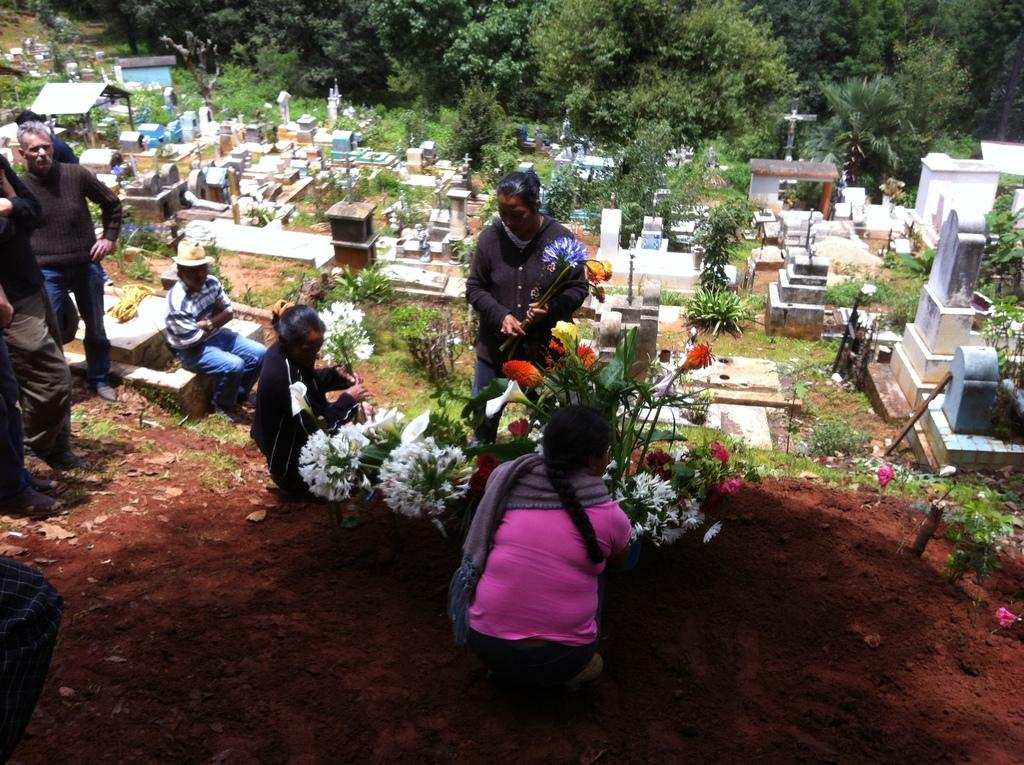What is the setting of the image? The setting of the image is a graveyard. What are the people in the image doing? The people in the image are sitting and standing. Are there any plants with flowers in the image? Yes, there are plants with flowers in the image. What can be seen in the background of the image? There are trees visible in the background of the image. How does the steam from the tramp's leg affect the flowers in the image? There is no tramp or steam present in the image, so this situation cannot be observed. 